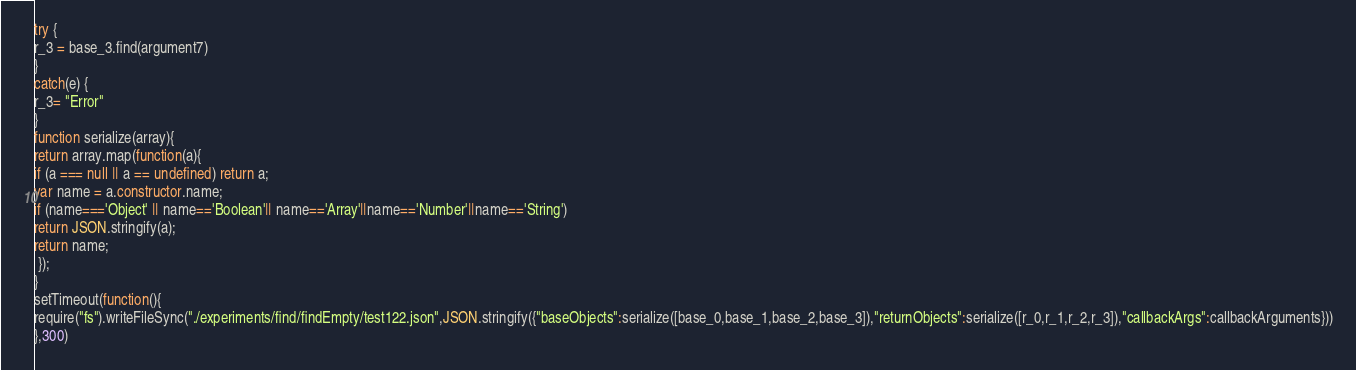<code> <loc_0><loc_0><loc_500><loc_500><_JavaScript_>try {
r_3 = base_3.find(argument7)
}
catch(e) {
r_3= "Error"
}
function serialize(array){
return array.map(function(a){
if (a === null || a == undefined) return a;
var name = a.constructor.name;
if (name==='Object' || name=='Boolean'|| name=='Array'||name=='Number'||name=='String')
return JSON.stringify(a);
return name;
 });
}
setTimeout(function(){
require("fs").writeFileSync("./experiments/find/findEmpty/test122.json",JSON.stringify({"baseObjects":serialize([base_0,base_1,base_2,base_3]),"returnObjects":serialize([r_0,r_1,r_2,r_3]),"callbackArgs":callbackArguments}))
},300)</code> 